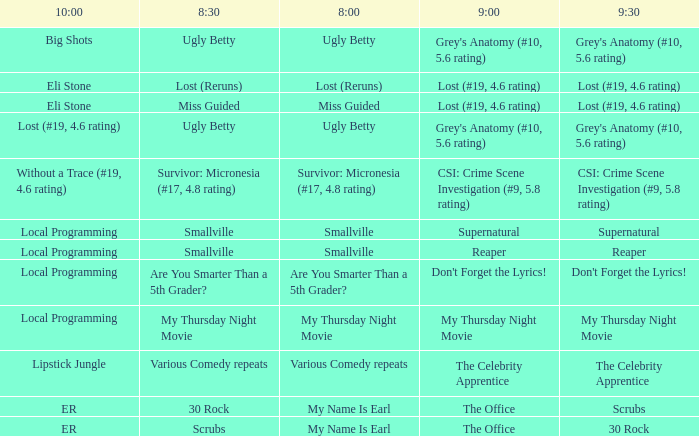What is at 10:00 when at 8:30 it is scrubs? ER. 